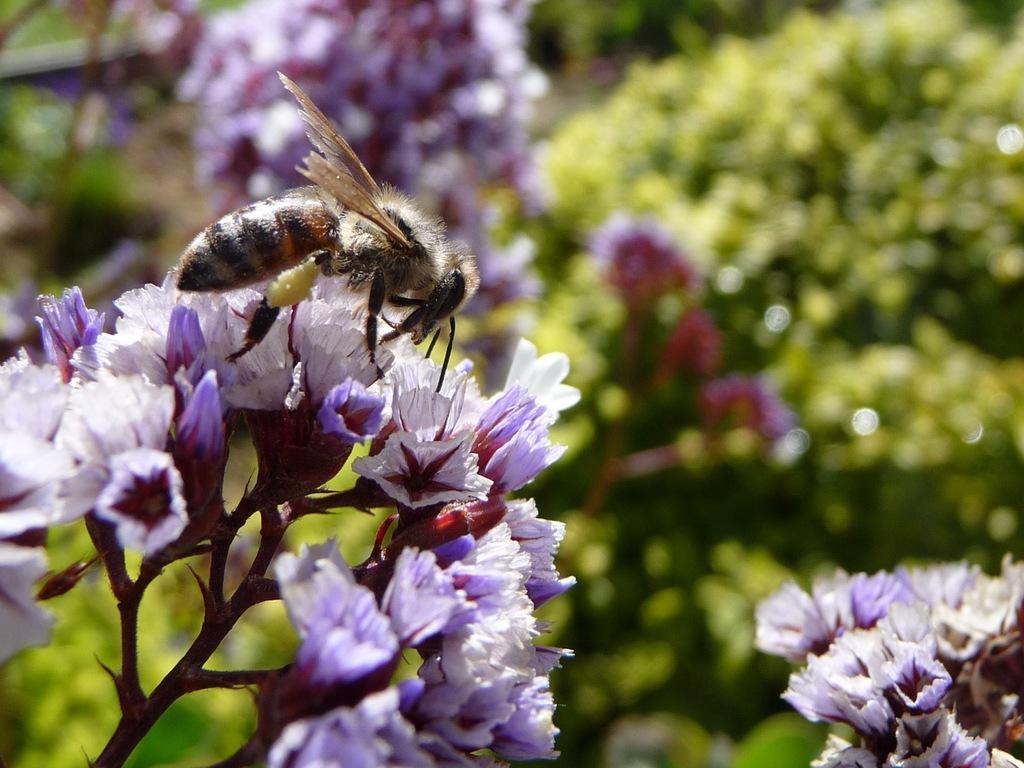Can you describe this image briefly? In this image I can see white and purple colour flowers. I can also see an insect over here and in the background I can see green colour. I can also see this image is little bit blurry from background. 